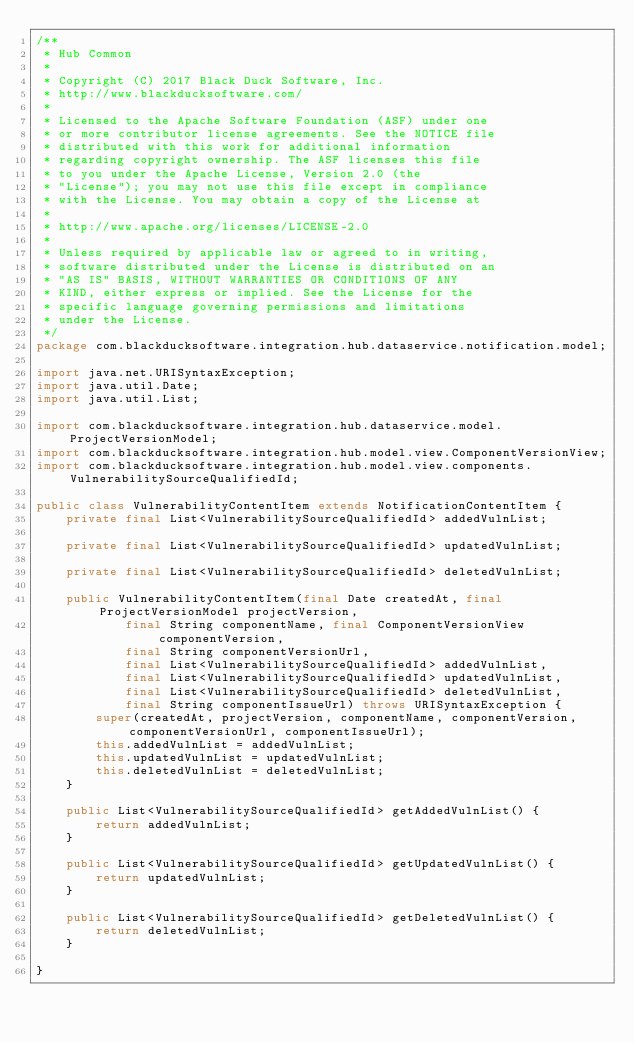Convert code to text. <code><loc_0><loc_0><loc_500><loc_500><_Java_>/**
 * Hub Common
 *
 * Copyright (C) 2017 Black Duck Software, Inc.
 * http://www.blackducksoftware.com/
 *
 * Licensed to the Apache Software Foundation (ASF) under one
 * or more contributor license agreements. See the NOTICE file
 * distributed with this work for additional information
 * regarding copyright ownership. The ASF licenses this file
 * to you under the Apache License, Version 2.0 (the
 * "License"); you may not use this file except in compliance
 * with the License. You may obtain a copy of the License at
 *
 * http://www.apache.org/licenses/LICENSE-2.0
 *
 * Unless required by applicable law or agreed to in writing,
 * software distributed under the License is distributed on an
 * "AS IS" BASIS, WITHOUT WARRANTIES OR CONDITIONS OF ANY
 * KIND, either express or implied. See the License for the
 * specific language governing permissions and limitations
 * under the License.
 */
package com.blackducksoftware.integration.hub.dataservice.notification.model;

import java.net.URISyntaxException;
import java.util.Date;
import java.util.List;

import com.blackducksoftware.integration.hub.dataservice.model.ProjectVersionModel;
import com.blackducksoftware.integration.hub.model.view.ComponentVersionView;
import com.blackducksoftware.integration.hub.model.view.components.VulnerabilitySourceQualifiedId;

public class VulnerabilityContentItem extends NotificationContentItem {
    private final List<VulnerabilitySourceQualifiedId> addedVulnList;

    private final List<VulnerabilitySourceQualifiedId> updatedVulnList;

    private final List<VulnerabilitySourceQualifiedId> deletedVulnList;

    public VulnerabilityContentItem(final Date createdAt, final ProjectVersionModel projectVersion,
            final String componentName, final ComponentVersionView componentVersion,
            final String componentVersionUrl,
            final List<VulnerabilitySourceQualifiedId> addedVulnList,
            final List<VulnerabilitySourceQualifiedId> updatedVulnList,
            final List<VulnerabilitySourceQualifiedId> deletedVulnList,
            final String componentIssueUrl) throws URISyntaxException {
        super(createdAt, projectVersion, componentName, componentVersion, componentVersionUrl, componentIssueUrl);
        this.addedVulnList = addedVulnList;
        this.updatedVulnList = updatedVulnList;
        this.deletedVulnList = deletedVulnList;
    }

    public List<VulnerabilitySourceQualifiedId> getAddedVulnList() {
        return addedVulnList;
    }

    public List<VulnerabilitySourceQualifiedId> getUpdatedVulnList() {
        return updatedVulnList;
    }

    public List<VulnerabilitySourceQualifiedId> getDeletedVulnList() {
        return deletedVulnList;
    }

}
</code> 